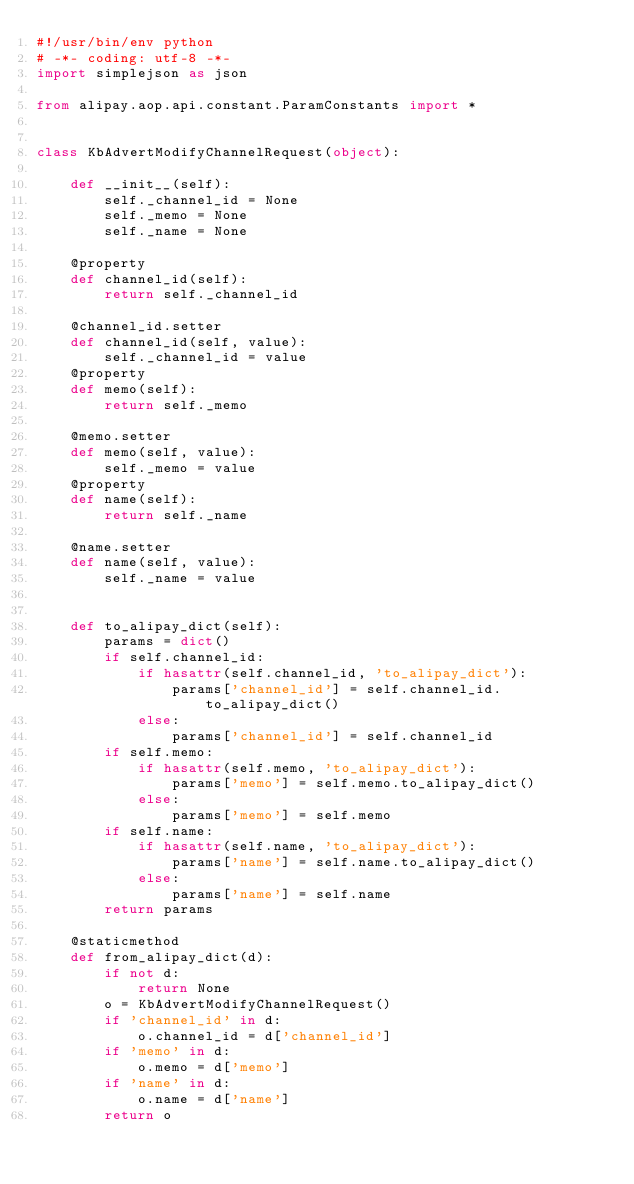<code> <loc_0><loc_0><loc_500><loc_500><_Python_>#!/usr/bin/env python
# -*- coding: utf-8 -*-
import simplejson as json

from alipay.aop.api.constant.ParamConstants import *


class KbAdvertModifyChannelRequest(object):

    def __init__(self):
        self._channel_id = None
        self._memo = None
        self._name = None

    @property
    def channel_id(self):
        return self._channel_id

    @channel_id.setter
    def channel_id(self, value):
        self._channel_id = value
    @property
    def memo(self):
        return self._memo

    @memo.setter
    def memo(self, value):
        self._memo = value
    @property
    def name(self):
        return self._name

    @name.setter
    def name(self, value):
        self._name = value


    def to_alipay_dict(self):
        params = dict()
        if self.channel_id:
            if hasattr(self.channel_id, 'to_alipay_dict'):
                params['channel_id'] = self.channel_id.to_alipay_dict()
            else:
                params['channel_id'] = self.channel_id
        if self.memo:
            if hasattr(self.memo, 'to_alipay_dict'):
                params['memo'] = self.memo.to_alipay_dict()
            else:
                params['memo'] = self.memo
        if self.name:
            if hasattr(self.name, 'to_alipay_dict'):
                params['name'] = self.name.to_alipay_dict()
            else:
                params['name'] = self.name
        return params

    @staticmethod
    def from_alipay_dict(d):
        if not d:
            return None
        o = KbAdvertModifyChannelRequest()
        if 'channel_id' in d:
            o.channel_id = d['channel_id']
        if 'memo' in d:
            o.memo = d['memo']
        if 'name' in d:
            o.name = d['name']
        return o


</code> 